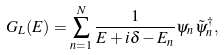<formula> <loc_0><loc_0><loc_500><loc_500>G _ { L } ( E ) = \sum _ { n = 1 } ^ { N } \frac { 1 } { E + i \delta - E _ { n } } \psi _ { n } \tilde { \psi } _ { n } ^ { \dagger } ,</formula> 